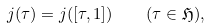Convert formula to latex. <formula><loc_0><loc_0><loc_500><loc_500>j ( \tau ) = j ( [ \tau , 1 ] ) \quad ( \tau \in \mathfrak { H } ) ,</formula> 